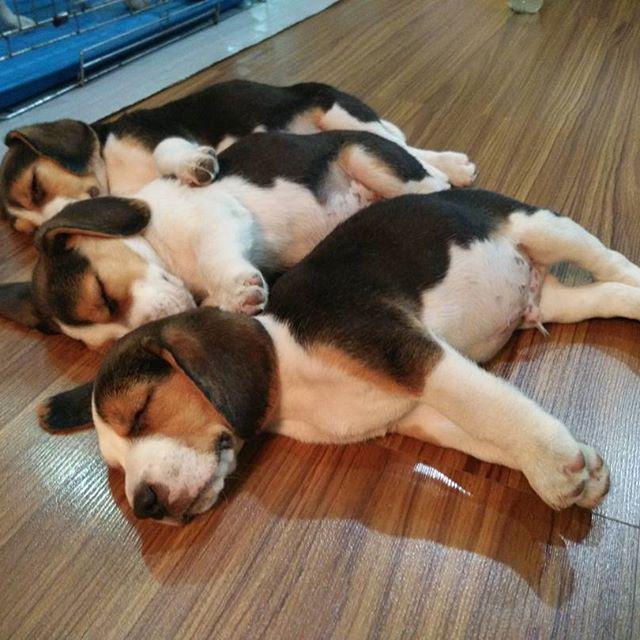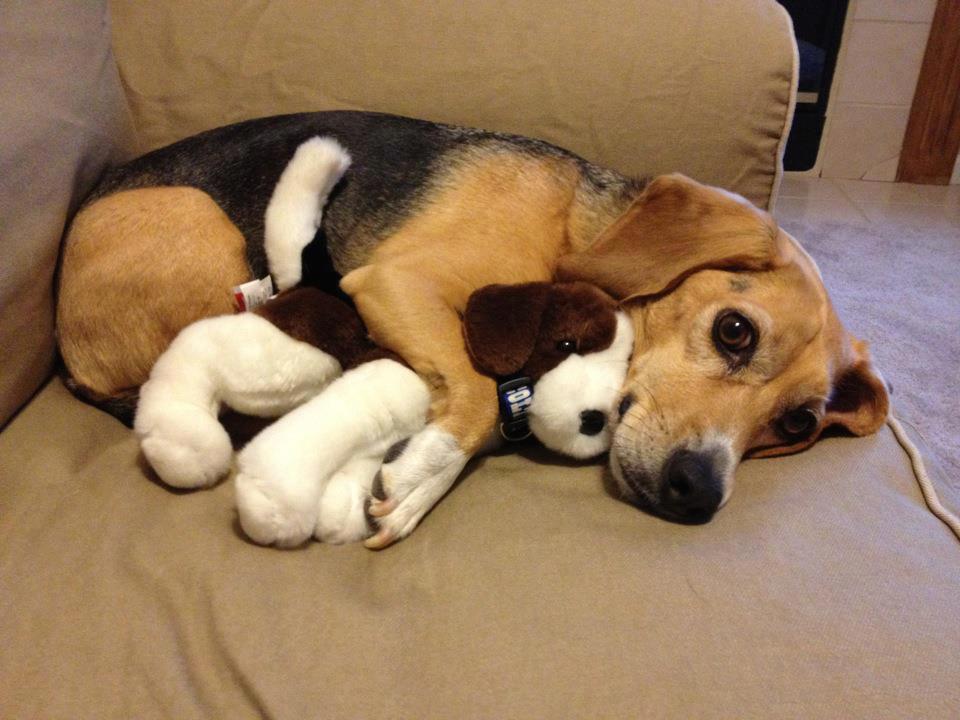The first image is the image on the left, the second image is the image on the right. Considering the images on both sides, is "One puppy is holding a stuffed animal." valid? Answer yes or no. Yes. The first image is the image on the left, the second image is the image on the right. Assess this claim about the two images: "In one image a dog lying on its side has a front leg over a stuffed animal which it has pulled close, while in a second image, at least two dogs are sleeping.". Correct or not? Answer yes or no. Yes. 